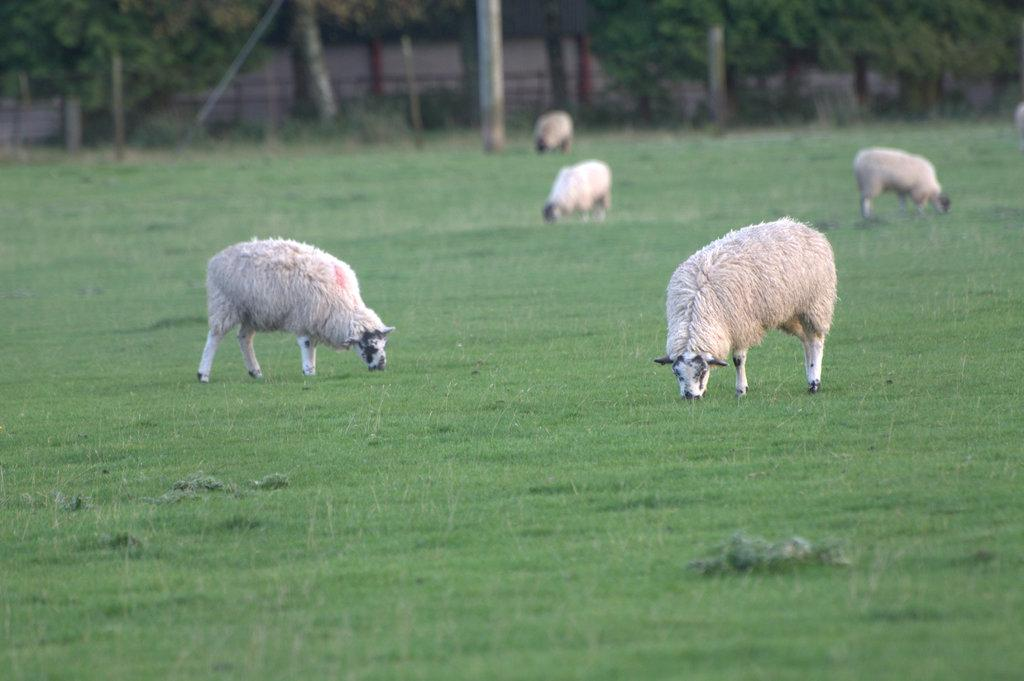How many animals are present in the image? There are five sheep in the image. What are the sheep doing in the image? The sheep are grazing. What type of vegetation can be seen at the bottom of the image? There is grass at the bottom of the image. What can be seen in the background of the image? There are trees in the background of the image. What type of cakes are being served to the sheep in the image? There are no cakes present in the image; the sheep are grazing on grass. What authority figure can be seen in the image? There is no authority figure present in the image; it features five sheep grazing in a grassy area with trees in the background. 